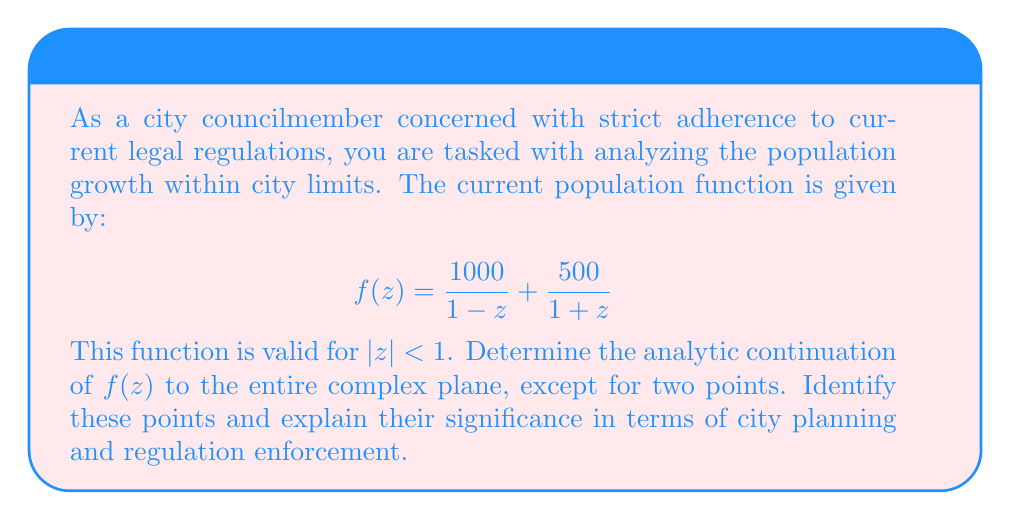What is the answer to this math problem? 1) First, we need to identify the singularities of the given function:
   $$f(z) = \frac{1000}{1-z} + \frac{500}{1+z}$$
   The singularities occur at $z=1$ and $z=-1$.

2) To find the analytic continuation, we can express $f(z)$ as a single fraction:
   $$f(z) = \frac{1000(1+z) + 500(1-z)}{(1-z)(1+z)}$$

3) Simplifying the numerator:
   $$f(z) = \frac{1000 + 1000z + 500 - 500z}{(1-z)(1+z)} = \frac{1500 + 500z}{(1-z)(1+z)}$$

4) This simplified form is valid for all complex numbers except $z=1$ and $z=-1$. It represents the analytic continuation of the original function to the entire complex plane, except for these two points.

5) The points $z=1$ and $z=-1$ are simple poles of the function. In terms of city planning and regulation enforcement:
   - $z=1$ could represent a point where population growth reaches a critical limit, potentially violating city regulations.
   - $z=-1$ might indicate a point where population decline becomes severe, possibly requiring intervention to maintain city services.

6) The analytic continuation allows us to predict population trends beyond the original domain, which is crucial for long-term city planning and ensuring compliance with regulations.
Answer: $f(z) = \frac{1500 + 500z}{(1-z)(1+z)}$, valid for all $z \in \mathbb{C}$ except $z=1$ and $z=-1$. 